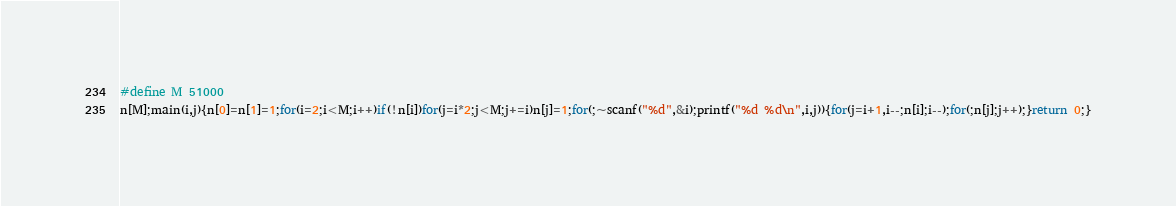Convert code to text. <code><loc_0><loc_0><loc_500><loc_500><_C_>#define M 51000
n[M];main(i,j){n[0]=n[1]=1;for(i=2;i<M;i++)if(!n[i])for(j=i*2;j<M;j+=i)n[j]=1;for(;~scanf("%d",&i);printf("%d %d\n",i,j)){for(j=i+1,i--;n[i];i--);for(;n[j];j++);}return 0;}</code> 